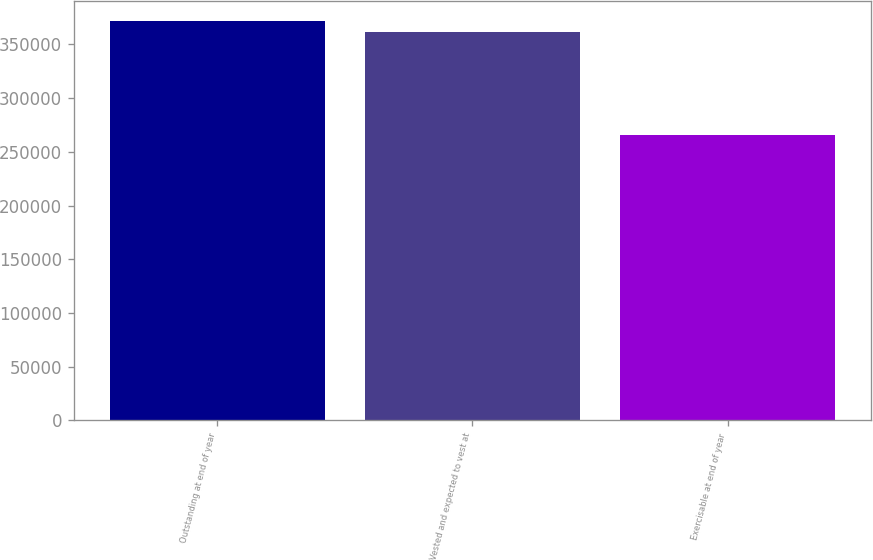Convert chart. <chart><loc_0><loc_0><loc_500><loc_500><bar_chart><fcel>Outstanding at end of year<fcel>Vested and expected to vest at<fcel>Exercisable at end of year<nl><fcel>371693<fcel>361496<fcel>265366<nl></chart> 